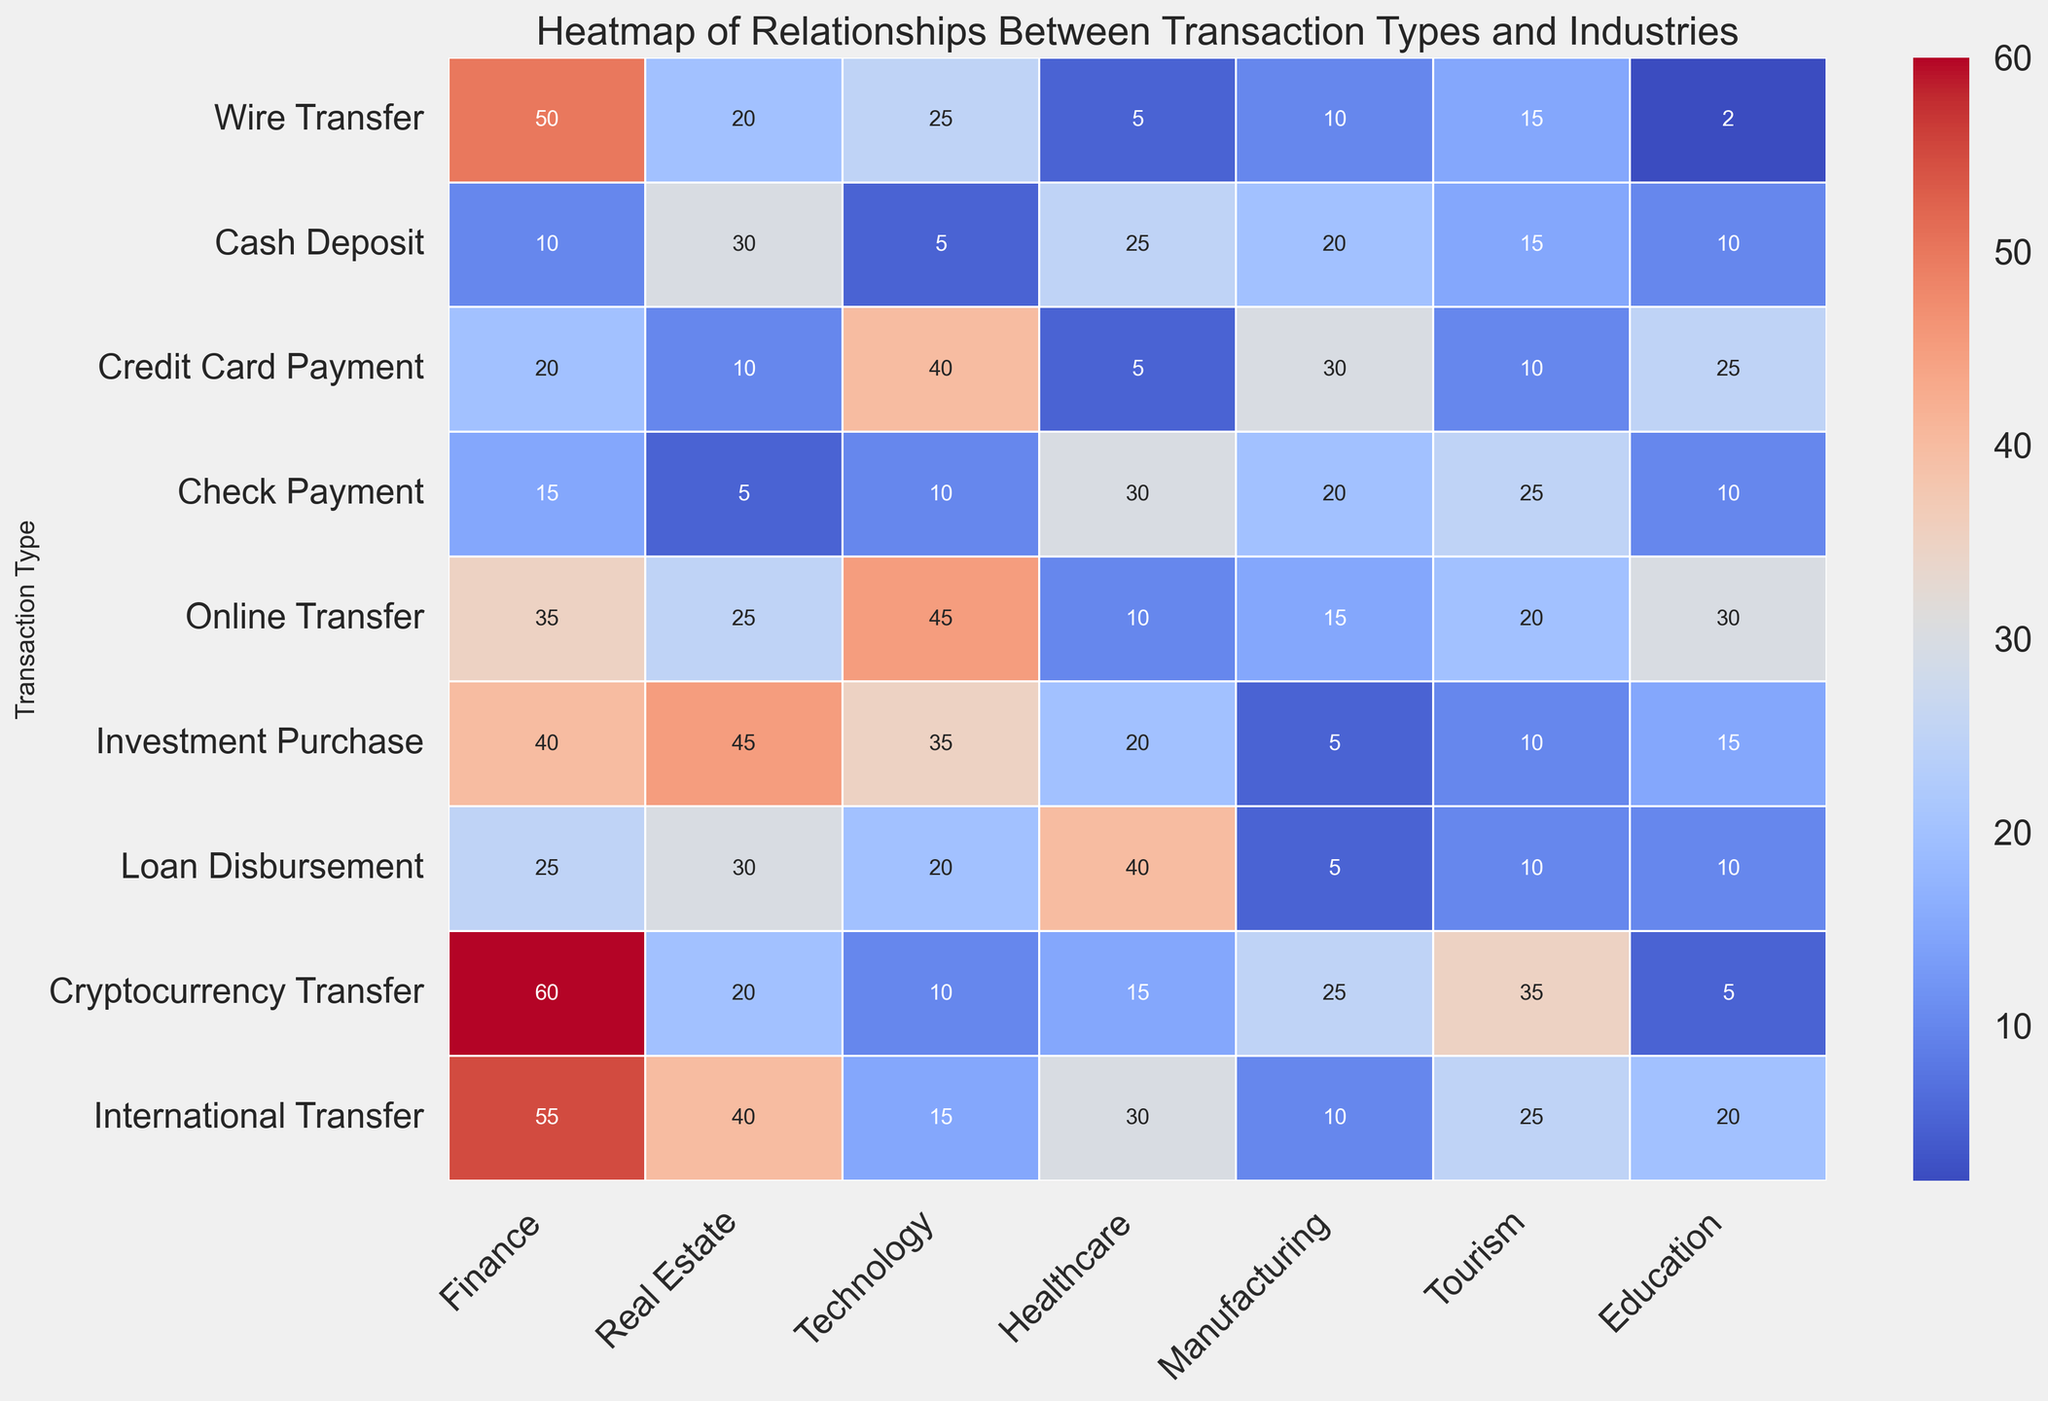Which transaction type has the highest occurrence in the Finance industry? To answer this, we look at the column titled "Finance" and identify the highest value. The highest is 60 for "Cryptocurrency Transfer."
Answer: Cryptocurrency Transfer Which industry has the lowest number of occurrences for Check Payment transactions? We examine the row for "Check Payment" and find the lowest value, which is 5 in "Real Estate."
Answer: Real Estate What is the total number of occurrences for Cash Deposit transactions across all industries? Add up all values in the "Cash Deposit" row: 10 + 30 + 5 + 25 + 20 + 15 + 10 = 115.
Answer: 115 Which industry has the most balanced distribution of transactions? We look for the industry columns where transaction values are relatively evenly distributed. "Tourism" with values 15, 15, 10, 25, 20, 10, 10, 35, 25 covers various transaction types fairly evenly.
Answer: Tourism How does the number of International Transfer transactions in Technology compare to those in Finance? Compare the values: Technology has 15 International Transfers while Finance has 55.
Answer: Finance has 40 more What is the average occurrence of Wire Transfers across all industries? Sum the Wire Transfer row and divide by the number of industries: (50 + 20 + 25 + 5 + 10 + 15 + 2) / 7 = 18.14.
Answer: 18.14 Which transaction type has more instances in Healthcare compared to Manufacturing? Compare values across both columns: "Loan Disbursement" is higher in Healthcare (40 vs. 5).
Answer: Loan Disbursement Identify the transaction type with the highest variability in occurrences across industries and explain your finding. Check the variance in all transaction rows: "Online Transfer" has ranges from 10 to 45. Variability is highest in this row.
Answer: Online Transfer Is the occurrence of Online Transfers higher or lower in Real Estate than in Tourism? Check values for Online Transfer: 25 in Real Estate, 20 in Tourism.
Answer: Higher in Real Estate 